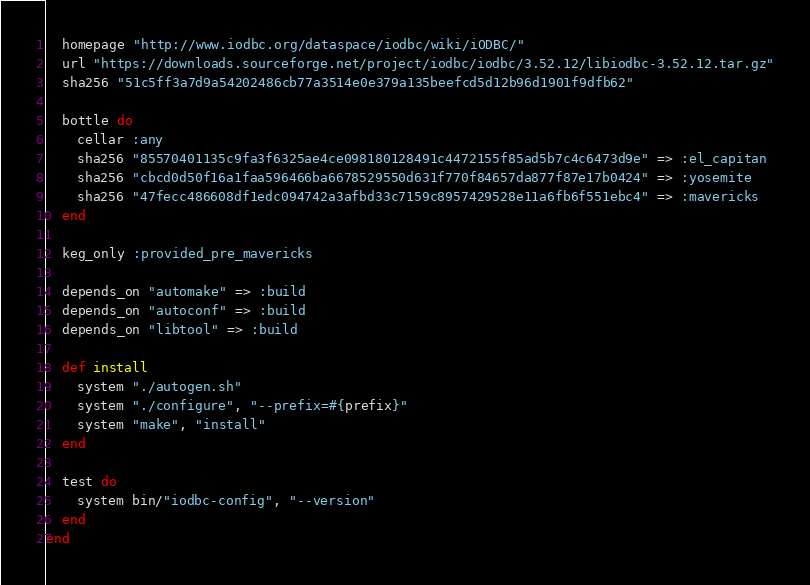<code> <loc_0><loc_0><loc_500><loc_500><_Ruby_>  homepage "http://www.iodbc.org/dataspace/iodbc/wiki/iODBC/"
  url "https://downloads.sourceforge.net/project/iodbc/iodbc/3.52.12/libiodbc-3.52.12.tar.gz"
  sha256 "51c5ff3a7d9a54202486cb77a3514e0e379a135beefcd5d12b96d1901f9dfb62"

  bottle do
    cellar :any
    sha256 "85570401135c9fa3f6325ae4ce098180128491c4472155f85ad5b7c4c6473d9e" => :el_capitan
    sha256 "cbcd0d50f16a1faa596466ba6678529550d631f770f84657da877f87e17b0424" => :yosemite
    sha256 "47fecc486608df1edc094742a3afbd33c7159c8957429528e11a6fb6f551ebc4" => :mavericks
  end

  keg_only :provided_pre_mavericks

  depends_on "automake" => :build
  depends_on "autoconf" => :build
  depends_on "libtool" => :build

  def install
    system "./autogen.sh"
    system "./configure", "--prefix=#{prefix}"
    system "make", "install"
  end

  test do
    system bin/"iodbc-config", "--version"
  end
end
</code> 